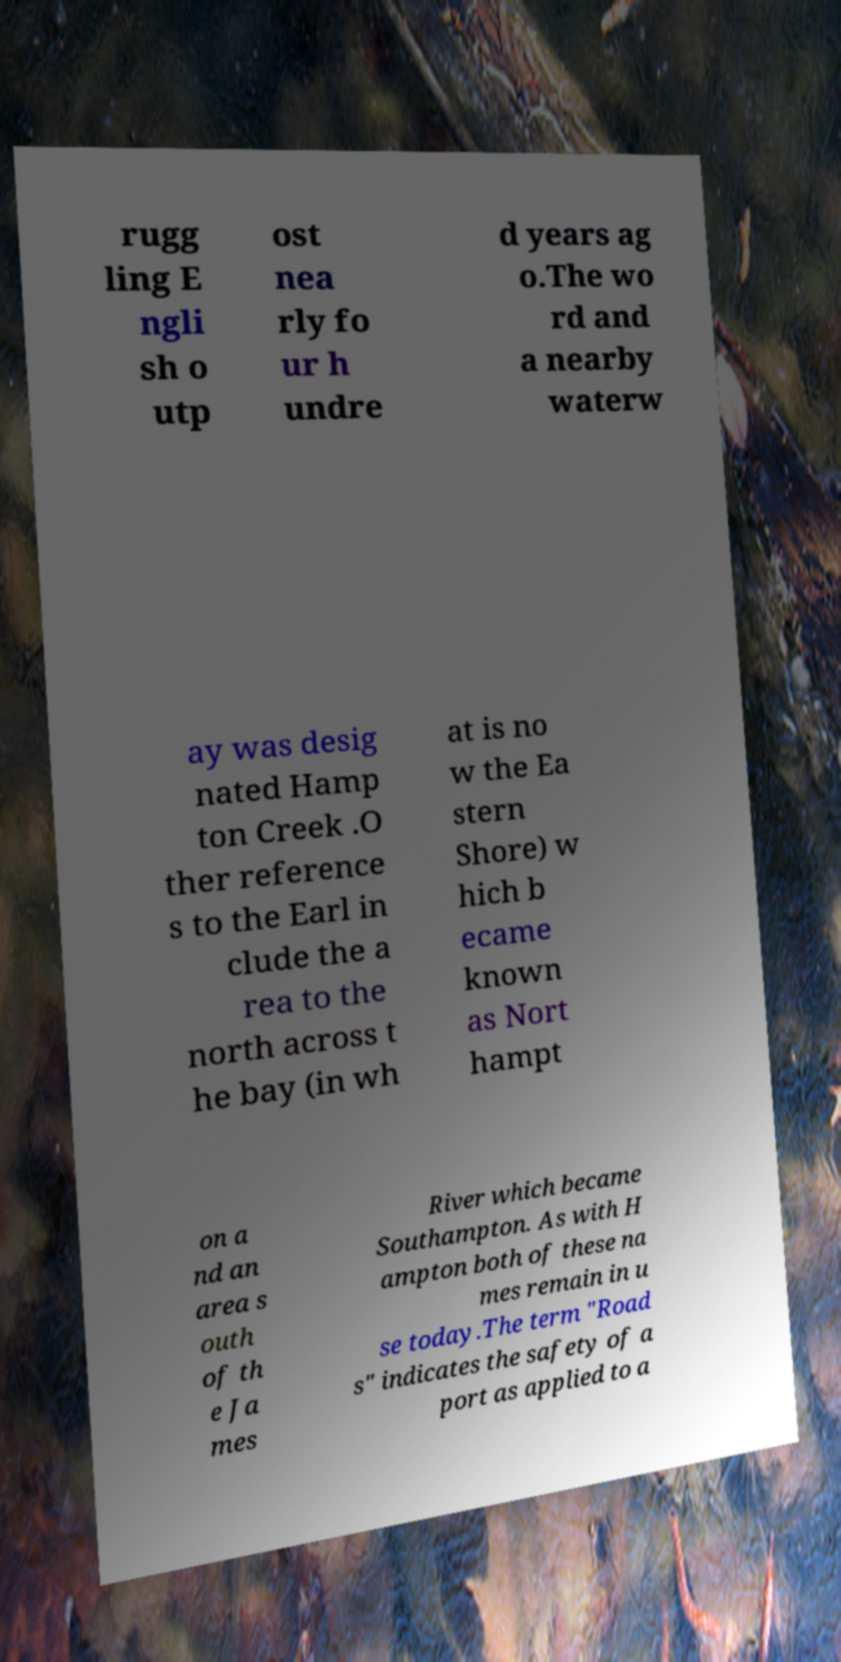Could you assist in decoding the text presented in this image and type it out clearly? rugg ling E ngli sh o utp ost nea rly fo ur h undre d years ag o.The wo rd and a nearby waterw ay was desig nated Hamp ton Creek .O ther reference s to the Earl in clude the a rea to the north across t he bay (in wh at is no w the Ea stern Shore) w hich b ecame known as Nort hampt on a nd an area s outh of th e Ja mes River which became Southampton. As with H ampton both of these na mes remain in u se today.The term "Road s" indicates the safety of a port as applied to a 